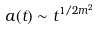<formula> <loc_0><loc_0><loc_500><loc_500>a ( t ) \sim t ^ { 1 / 2 m ^ { 2 } }</formula> 